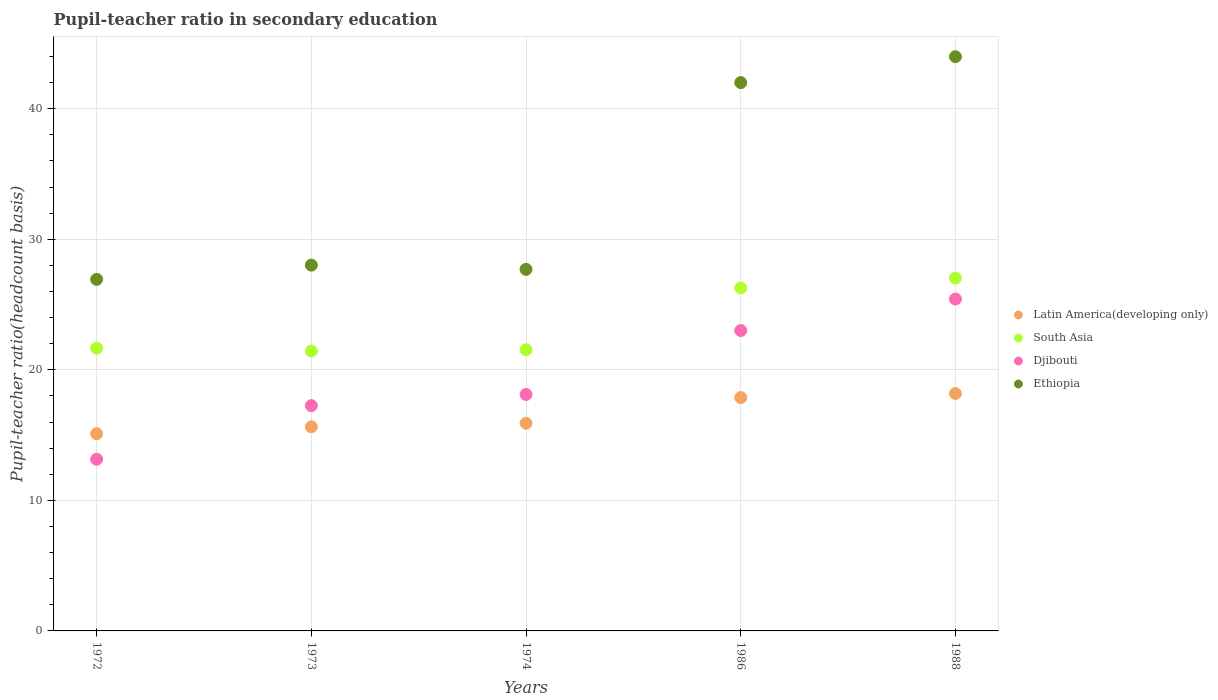How many different coloured dotlines are there?
Give a very brief answer. 4. Is the number of dotlines equal to the number of legend labels?
Your answer should be very brief. Yes. What is the pupil-teacher ratio in secondary education in Latin America(developing only) in 1974?
Provide a short and direct response. 15.91. Across all years, what is the maximum pupil-teacher ratio in secondary education in Latin America(developing only)?
Provide a short and direct response. 18.19. Across all years, what is the minimum pupil-teacher ratio in secondary education in Latin America(developing only)?
Your answer should be very brief. 15.11. What is the total pupil-teacher ratio in secondary education in Latin America(developing only) in the graph?
Keep it short and to the point. 82.71. What is the difference between the pupil-teacher ratio in secondary education in Ethiopia in 1974 and that in 1988?
Your response must be concise. -16.29. What is the difference between the pupil-teacher ratio in secondary education in Ethiopia in 1988 and the pupil-teacher ratio in secondary education in Djibouti in 1974?
Your answer should be compact. 25.87. What is the average pupil-teacher ratio in secondary education in Djibouti per year?
Make the answer very short. 19.39. In the year 1986, what is the difference between the pupil-teacher ratio in secondary education in Djibouti and pupil-teacher ratio in secondary education in South Asia?
Your answer should be compact. -3.26. In how many years, is the pupil-teacher ratio in secondary education in Latin America(developing only) greater than 40?
Provide a succinct answer. 0. What is the ratio of the pupil-teacher ratio in secondary education in Latin America(developing only) in 1974 to that in 1988?
Give a very brief answer. 0.87. Is the difference between the pupil-teacher ratio in secondary education in Djibouti in 1972 and 1986 greater than the difference between the pupil-teacher ratio in secondary education in South Asia in 1972 and 1986?
Give a very brief answer. No. What is the difference between the highest and the second highest pupil-teacher ratio in secondary education in Latin America(developing only)?
Provide a short and direct response. 0.31. What is the difference between the highest and the lowest pupil-teacher ratio in secondary education in South Asia?
Provide a short and direct response. 5.59. Is it the case that in every year, the sum of the pupil-teacher ratio in secondary education in Ethiopia and pupil-teacher ratio in secondary education in Djibouti  is greater than the pupil-teacher ratio in secondary education in Latin America(developing only)?
Make the answer very short. Yes. Is the pupil-teacher ratio in secondary education in Ethiopia strictly less than the pupil-teacher ratio in secondary education in Latin America(developing only) over the years?
Keep it short and to the point. No. What is the difference between two consecutive major ticks on the Y-axis?
Give a very brief answer. 10. Does the graph contain any zero values?
Offer a terse response. No. Does the graph contain grids?
Ensure brevity in your answer.  Yes. Where does the legend appear in the graph?
Give a very brief answer. Center right. How many legend labels are there?
Offer a terse response. 4. What is the title of the graph?
Your response must be concise. Pupil-teacher ratio in secondary education. Does "East Asia (all income levels)" appear as one of the legend labels in the graph?
Provide a short and direct response. No. What is the label or title of the Y-axis?
Ensure brevity in your answer.  Pupil-teacher ratio(headcount basis). What is the Pupil-teacher ratio(headcount basis) in Latin America(developing only) in 1972?
Your answer should be very brief. 15.11. What is the Pupil-teacher ratio(headcount basis) in South Asia in 1972?
Give a very brief answer. 21.66. What is the Pupil-teacher ratio(headcount basis) of Djibouti in 1972?
Your answer should be very brief. 13.15. What is the Pupil-teacher ratio(headcount basis) in Ethiopia in 1972?
Your answer should be very brief. 26.93. What is the Pupil-teacher ratio(headcount basis) of Latin America(developing only) in 1973?
Give a very brief answer. 15.63. What is the Pupil-teacher ratio(headcount basis) in South Asia in 1973?
Provide a succinct answer. 21.44. What is the Pupil-teacher ratio(headcount basis) of Djibouti in 1973?
Offer a very short reply. 17.26. What is the Pupil-teacher ratio(headcount basis) in Ethiopia in 1973?
Make the answer very short. 28.02. What is the Pupil-teacher ratio(headcount basis) in Latin America(developing only) in 1974?
Ensure brevity in your answer.  15.91. What is the Pupil-teacher ratio(headcount basis) of South Asia in 1974?
Your answer should be very brief. 21.54. What is the Pupil-teacher ratio(headcount basis) in Djibouti in 1974?
Provide a succinct answer. 18.11. What is the Pupil-teacher ratio(headcount basis) in Ethiopia in 1974?
Your answer should be very brief. 27.69. What is the Pupil-teacher ratio(headcount basis) of Latin America(developing only) in 1986?
Ensure brevity in your answer.  17.88. What is the Pupil-teacher ratio(headcount basis) of South Asia in 1986?
Provide a short and direct response. 26.27. What is the Pupil-teacher ratio(headcount basis) in Djibouti in 1986?
Your answer should be compact. 23.01. What is the Pupil-teacher ratio(headcount basis) of Ethiopia in 1986?
Ensure brevity in your answer.  42. What is the Pupil-teacher ratio(headcount basis) of Latin America(developing only) in 1988?
Provide a succinct answer. 18.19. What is the Pupil-teacher ratio(headcount basis) of South Asia in 1988?
Provide a succinct answer. 27.03. What is the Pupil-teacher ratio(headcount basis) of Djibouti in 1988?
Offer a very short reply. 25.43. What is the Pupil-teacher ratio(headcount basis) of Ethiopia in 1988?
Provide a succinct answer. 43.98. Across all years, what is the maximum Pupil-teacher ratio(headcount basis) in Latin America(developing only)?
Your answer should be compact. 18.19. Across all years, what is the maximum Pupil-teacher ratio(headcount basis) of South Asia?
Offer a terse response. 27.03. Across all years, what is the maximum Pupil-teacher ratio(headcount basis) in Djibouti?
Your answer should be very brief. 25.43. Across all years, what is the maximum Pupil-teacher ratio(headcount basis) in Ethiopia?
Provide a succinct answer. 43.98. Across all years, what is the minimum Pupil-teacher ratio(headcount basis) of Latin America(developing only)?
Ensure brevity in your answer.  15.11. Across all years, what is the minimum Pupil-teacher ratio(headcount basis) of South Asia?
Offer a terse response. 21.44. Across all years, what is the minimum Pupil-teacher ratio(headcount basis) of Djibouti?
Provide a succinct answer. 13.15. Across all years, what is the minimum Pupil-teacher ratio(headcount basis) of Ethiopia?
Your response must be concise. 26.93. What is the total Pupil-teacher ratio(headcount basis) in Latin America(developing only) in the graph?
Provide a short and direct response. 82.71. What is the total Pupil-teacher ratio(headcount basis) in South Asia in the graph?
Keep it short and to the point. 117.93. What is the total Pupil-teacher ratio(headcount basis) in Djibouti in the graph?
Your answer should be compact. 96.96. What is the total Pupil-teacher ratio(headcount basis) in Ethiopia in the graph?
Make the answer very short. 168.63. What is the difference between the Pupil-teacher ratio(headcount basis) of Latin America(developing only) in 1972 and that in 1973?
Ensure brevity in your answer.  -0.53. What is the difference between the Pupil-teacher ratio(headcount basis) in South Asia in 1972 and that in 1973?
Provide a succinct answer. 0.22. What is the difference between the Pupil-teacher ratio(headcount basis) of Djibouti in 1972 and that in 1973?
Your answer should be very brief. -4.11. What is the difference between the Pupil-teacher ratio(headcount basis) of Ethiopia in 1972 and that in 1973?
Your response must be concise. -1.09. What is the difference between the Pupil-teacher ratio(headcount basis) of Latin America(developing only) in 1972 and that in 1974?
Your answer should be compact. -0.8. What is the difference between the Pupil-teacher ratio(headcount basis) of South Asia in 1972 and that in 1974?
Offer a very short reply. 0.12. What is the difference between the Pupil-teacher ratio(headcount basis) in Djibouti in 1972 and that in 1974?
Provide a succinct answer. -4.96. What is the difference between the Pupil-teacher ratio(headcount basis) of Ethiopia in 1972 and that in 1974?
Your response must be concise. -0.76. What is the difference between the Pupil-teacher ratio(headcount basis) in Latin America(developing only) in 1972 and that in 1986?
Your answer should be very brief. -2.77. What is the difference between the Pupil-teacher ratio(headcount basis) in South Asia in 1972 and that in 1986?
Make the answer very short. -4.61. What is the difference between the Pupil-teacher ratio(headcount basis) of Djibouti in 1972 and that in 1986?
Your response must be concise. -9.86. What is the difference between the Pupil-teacher ratio(headcount basis) in Ethiopia in 1972 and that in 1986?
Make the answer very short. -15.07. What is the difference between the Pupil-teacher ratio(headcount basis) of Latin America(developing only) in 1972 and that in 1988?
Provide a short and direct response. -3.08. What is the difference between the Pupil-teacher ratio(headcount basis) of South Asia in 1972 and that in 1988?
Your response must be concise. -5.37. What is the difference between the Pupil-teacher ratio(headcount basis) in Djibouti in 1972 and that in 1988?
Make the answer very short. -12.28. What is the difference between the Pupil-teacher ratio(headcount basis) of Ethiopia in 1972 and that in 1988?
Make the answer very short. -17.05. What is the difference between the Pupil-teacher ratio(headcount basis) in Latin America(developing only) in 1973 and that in 1974?
Keep it short and to the point. -0.27. What is the difference between the Pupil-teacher ratio(headcount basis) in South Asia in 1973 and that in 1974?
Keep it short and to the point. -0.1. What is the difference between the Pupil-teacher ratio(headcount basis) of Djibouti in 1973 and that in 1974?
Offer a very short reply. -0.86. What is the difference between the Pupil-teacher ratio(headcount basis) in Ethiopia in 1973 and that in 1974?
Make the answer very short. 0.33. What is the difference between the Pupil-teacher ratio(headcount basis) of Latin America(developing only) in 1973 and that in 1986?
Make the answer very short. -2.24. What is the difference between the Pupil-teacher ratio(headcount basis) in South Asia in 1973 and that in 1986?
Provide a short and direct response. -4.83. What is the difference between the Pupil-teacher ratio(headcount basis) of Djibouti in 1973 and that in 1986?
Give a very brief answer. -5.75. What is the difference between the Pupil-teacher ratio(headcount basis) in Ethiopia in 1973 and that in 1986?
Provide a short and direct response. -13.98. What is the difference between the Pupil-teacher ratio(headcount basis) of Latin America(developing only) in 1973 and that in 1988?
Give a very brief answer. -2.55. What is the difference between the Pupil-teacher ratio(headcount basis) of South Asia in 1973 and that in 1988?
Your answer should be very brief. -5.59. What is the difference between the Pupil-teacher ratio(headcount basis) in Djibouti in 1973 and that in 1988?
Make the answer very short. -8.17. What is the difference between the Pupil-teacher ratio(headcount basis) of Ethiopia in 1973 and that in 1988?
Your response must be concise. -15.96. What is the difference between the Pupil-teacher ratio(headcount basis) of Latin America(developing only) in 1974 and that in 1986?
Your answer should be compact. -1.97. What is the difference between the Pupil-teacher ratio(headcount basis) in South Asia in 1974 and that in 1986?
Ensure brevity in your answer.  -4.73. What is the difference between the Pupil-teacher ratio(headcount basis) in Djibouti in 1974 and that in 1986?
Keep it short and to the point. -4.9. What is the difference between the Pupil-teacher ratio(headcount basis) of Ethiopia in 1974 and that in 1986?
Your answer should be very brief. -14.31. What is the difference between the Pupil-teacher ratio(headcount basis) of Latin America(developing only) in 1974 and that in 1988?
Offer a very short reply. -2.28. What is the difference between the Pupil-teacher ratio(headcount basis) in South Asia in 1974 and that in 1988?
Your answer should be compact. -5.49. What is the difference between the Pupil-teacher ratio(headcount basis) in Djibouti in 1974 and that in 1988?
Offer a very short reply. -7.31. What is the difference between the Pupil-teacher ratio(headcount basis) in Ethiopia in 1974 and that in 1988?
Make the answer very short. -16.29. What is the difference between the Pupil-teacher ratio(headcount basis) in Latin America(developing only) in 1986 and that in 1988?
Your answer should be very brief. -0.31. What is the difference between the Pupil-teacher ratio(headcount basis) of South Asia in 1986 and that in 1988?
Offer a very short reply. -0.76. What is the difference between the Pupil-teacher ratio(headcount basis) in Djibouti in 1986 and that in 1988?
Your response must be concise. -2.42. What is the difference between the Pupil-teacher ratio(headcount basis) in Ethiopia in 1986 and that in 1988?
Give a very brief answer. -1.98. What is the difference between the Pupil-teacher ratio(headcount basis) in Latin America(developing only) in 1972 and the Pupil-teacher ratio(headcount basis) in South Asia in 1973?
Provide a short and direct response. -6.33. What is the difference between the Pupil-teacher ratio(headcount basis) in Latin America(developing only) in 1972 and the Pupil-teacher ratio(headcount basis) in Djibouti in 1973?
Your answer should be very brief. -2.15. What is the difference between the Pupil-teacher ratio(headcount basis) in Latin America(developing only) in 1972 and the Pupil-teacher ratio(headcount basis) in Ethiopia in 1973?
Provide a succinct answer. -12.91. What is the difference between the Pupil-teacher ratio(headcount basis) in South Asia in 1972 and the Pupil-teacher ratio(headcount basis) in Djibouti in 1973?
Ensure brevity in your answer.  4.4. What is the difference between the Pupil-teacher ratio(headcount basis) in South Asia in 1972 and the Pupil-teacher ratio(headcount basis) in Ethiopia in 1973?
Offer a terse response. -6.36. What is the difference between the Pupil-teacher ratio(headcount basis) of Djibouti in 1972 and the Pupil-teacher ratio(headcount basis) of Ethiopia in 1973?
Provide a succinct answer. -14.87. What is the difference between the Pupil-teacher ratio(headcount basis) in Latin America(developing only) in 1972 and the Pupil-teacher ratio(headcount basis) in South Asia in 1974?
Make the answer very short. -6.43. What is the difference between the Pupil-teacher ratio(headcount basis) in Latin America(developing only) in 1972 and the Pupil-teacher ratio(headcount basis) in Djibouti in 1974?
Provide a short and direct response. -3.01. What is the difference between the Pupil-teacher ratio(headcount basis) of Latin America(developing only) in 1972 and the Pupil-teacher ratio(headcount basis) of Ethiopia in 1974?
Make the answer very short. -12.59. What is the difference between the Pupil-teacher ratio(headcount basis) of South Asia in 1972 and the Pupil-teacher ratio(headcount basis) of Djibouti in 1974?
Make the answer very short. 3.54. What is the difference between the Pupil-teacher ratio(headcount basis) of South Asia in 1972 and the Pupil-teacher ratio(headcount basis) of Ethiopia in 1974?
Your answer should be very brief. -6.04. What is the difference between the Pupil-teacher ratio(headcount basis) of Djibouti in 1972 and the Pupil-teacher ratio(headcount basis) of Ethiopia in 1974?
Your answer should be compact. -14.54. What is the difference between the Pupil-teacher ratio(headcount basis) of Latin America(developing only) in 1972 and the Pupil-teacher ratio(headcount basis) of South Asia in 1986?
Keep it short and to the point. -11.16. What is the difference between the Pupil-teacher ratio(headcount basis) in Latin America(developing only) in 1972 and the Pupil-teacher ratio(headcount basis) in Djibouti in 1986?
Ensure brevity in your answer.  -7.9. What is the difference between the Pupil-teacher ratio(headcount basis) of Latin America(developing only) in 1972 and the Pupil-teacher ratio(headcount basis) of Ethiopia in 1986?
Your answer should be very brief. -26.89. What is the difference between the Pupil-teacher ratio(headcount basis) of South Asia in 1972 and the Pupil-teacher ratio(headcount basis) of Djibouti in 1986?
Ensure brevity in your answer.  -1.35. What is the difference between the Pupil-teacher ratio(headcount basis) of South Asia in 1972 and the Pupil-teacher ratio(headcount basis) of Ethiopia in 1986?
Ensure brevity in your answer.  -20.34. What is the difference between the Pupil-teacher ratio(headcount basis) of Djibouti in 1972 and the Pupil-teacher ratio(headcount basis) of Ethiopia in 1986?
Keep it short and to the point. -28.85. What is the difference between the Pupil-teacher ratio(headcount basis) of Latin America(developing only) in 1972 and the Pupil-teacher ratio(headcount basis) of South Asia in 1988?
Your response must be concise. -11.92. What is the difference between the Pupil-teacher ratio(headcount basis) in Latin America(developing only) in 1972 and the Pupil-teacher ratio(headcount basis) in Djibouti in 1988?
Your answer should be very brief. -10.32. What is the difference between the Pupil-teacher ratio(headcount basis) of Latin America(developing only) in 1972 and the Pupil-teacher ratio(headcount basis) of Ethiopia in 1988?
Ensure brevity in your answer.  -28.88. What is the difference between the Pupil-teacher ratio(headcount basis) in South Asia in 1972 and the Pupil-teacher ratio(headcount basis) in Djibouti in 1988?
Your answer should be very brief. -3.77. What is the difference between the Pupil-teacher ratio(headcount basis) of South Asia in 1972 and the Pupil-teacher ratio(headcount basis) of Ethiopia in 1988?
Ensure brevity in your answer.  -22.33. What is the difference between the Pupil-teacher ratio(headcount basis) in Djibouti in 1972 and the Pupil-teacher ratio(headcount basis) in Ethiopia in 1988?
Your answer should be compact. -30.83. What is the difference between the Pupil-teacher ratio(headcount basis) of Latin America(developing only) in 1973 and the Pupil-teacher ratio(headcount basis) of South Asia in 1974?
Ensure brevity in your answer.  -5.9. What is the difference between the Pupil-teacher ratio(headcount basis) of Latin America(developing only) in 1973 and the Pupil-teacher ratio(headcount basis) of Djibouti in 1974?
Your response must be concise. -2.48. What is the difference between the Pupil-teacher ratio(headcount basis) in Latin America(developing only) in 1973 and the Pupil-teacher ratio(headcount basis) in Ethiopia in 1974?
Your response must be concise. -12.06. What is the difference between the Pupil-teacher ratio(headcount basis) of South Asia in 1973 and the Pupil-teacher ratio(headcount basis) of Djibouti in 1974?
Make the answer very short. 3.33. What is the difference between the Pupil-teacher ratio(headcount basis) in South Asia in 1973 and the Pupil-teacher ratio(headcount basis) in Ethiopia in 1974?
Keep it short and to the point. -6.25. What is the difference between the Pupil-teacher ratio(headcount basis) in Djibouti in 1973 and the Pupil-teacher ratio(headcount basis) in Ethiopia in 1974?
Provide a succinct answer. -10.44. What is the difference between the Pupil-teacher ratio(headcount basis) in Latin America(developing only) in 1973 and the Pupil-teacher ratio(headcount basis) in South Asia in 1986?
Ensure brevity in your answer.  -10.63. What is the difference between the Pupil-teacher ratio(headcount basis) in Latin America(developing only) in 1973 and the Pupil-teacher ratio(headcount basis) in Djibouti in 1986?
Give a very brief answer. -7.38. What is the difference between the Pupil-teacher ratio(headcount basis) in Latin America(developing only) in 1973 and the Pupil-teacher ratio(headcount basis) in Ethiopia in 1986?
Ensure brevity in your answer.  -26.37. What is the difference between the Pupil-teacher ratio(headcount basis) of South Asia in 1973 and the Pupil-teacher ratio(headcount basis) of Djibouti in 1986?
Give a very brief answer. -1.57. What is the difference between the Pupil-teacher ratio(headcount basis) in South Asia in 1973 and the Pupil-teacher ratio(headcount basis) in Ethiopia in 1986?
Ensure brevity in your answer.  -20.56. What is the difference between the Pupil-teacher ratio(headcount basis) of Djibouti in 1973 and the Pupil-teacher ratio(headcount basis) of Ethiopia in 1986?
Offer a very short reply. -24.74. What is the difference between the Pupil-teacher ratio(headcount basis) in Latin America(developing only) in 1973 and the Pupil-teacher ratio(headcount basis) in South Asia in 1988?
Provide a succinct answer. -11.39. What is the difference between the Pupil-teacher ratio(headcount basis) in Latin America(developing only) in 1973 and the Pupil-teacher ratio(headcount basis) in Djibouti in 1988?
Your response must be concise. -9.79. What is the difference between the Pupil-teacher ratio(headcount basis) of Latin America(developing only) in 1973 and the Pupil-teacher ratio(headcount basis) of Ethiopia in 1988?
Provide a short and direct response. -28.35. What is the difference between the Pupil-teacher ratio(headcount basis) in South Asia in 1973 and the Pupil-teacher ratio(headcount basis) in Djibouti in 1988?
Keep it short and to the point. -3.98. What is the difference between the Pupil-teacher ratio(headcount basis) of South Asia in 1973 and the Pupil-teacher ratio(headcount basis) of Ethiopia in 1988?
Your response must be concise. -22.54. What is the difference between the Pupil-teacher ratio(headcount basis) in Djibouti in 1973 and the Pupil-teacher ratio(headcount basis) in Ethiopia in 1988?
Offer a very short reply. -26.73. What is the difference between the Pupil-teacher ratio(headcount basis) in Latin America(developing only) in 1974 and the Pupil-teacher ratio(headcount basis) in South Asia in 1986?
Make the answer very short. -10.36. What is the difference between the Pupil-teacher ratio(headcount basis) in Latin America(developing only) in 1974 and the Pupil-teacher ratio(headcount basis) in Djibouti in 1986?
Your response must be concise. -7.1. What is the difference between the Pupil-teacher ratio(headcount basis) of Latin America(developing only) in 1974 and the Pupil-teacher ratio(headcount basis) of Ethiopia in 1986?
Offer a terse response. -26.09. What is the difference between the Pupil-teacher ratio(headcount basis) in South Asia in 1974 and the Pupil-teacher ratio(headcount basis) in Djibouti in 1986?
Your answer should be compact. -1.47. What is the difference between the Pupil-teacher ratio(headcount basis) of South Asia in 1974 and the Pupil-teacher ratio(headcount basis) of Ethiopia in 1986?
Ensure brevity in your answer.  -20.46. What is the difference between the Pupil-teacher ratio(headcount basis) in Djibouti in 1974 and the Pupil-teacher ratio(headcount basis) in Ethiopia in 1986?
Make the answer very short. -23.89. What is the difference between the Pupil-teacher ratio(headcount basis) of Latin America(developing only) in 1974 and the Pupil-teacher ratio(headcount basis) of South Asia in 1988?
Ensure brevity in your answer.  -11.12. What is the difference between the Pupil-teacher ratio(headcount basis) in Latin America(developing only) in 1974 and the Pupil-teacher ratio(headcount basis) in Djibouti in 1988?
Provide a short and direct response. -9.52. What is the difference between the Pupil-teacher ratio(headcount basis) in Latin America(developing only) in 1974 and the Pupil-teacher ratio(headcount basis) in Ethiopia in 1988?
Give a very brief answer. -28.08. What is the difference between the Pupil-teacher ratio(headcount basis) in South Asia in 1974 and the Pupil-teacher ratio(headcount basis) in Djibouti in 1988?
Provide a short and direct response. -3.89. What is the difference between the Pupil-teacher ratio(headcount basis) of South Asia in 1974 and the Pupil-teacher ratio(headcount basis) of Ethiopia in 1988?
Offer a terse response. -22.45. What is the difference between the Pupil-teacher ratio(headcount basis) of Djibouti in 1974 and the Pupil-teacher ratio(headcount basis) of Ethiopia in 1988?
Keep it short and to the point. -25.87. What is the difference between the Pupil-teacher ratio(headcount basis) in Latin America(developing only) in 1986 and the Pupil-teacher ratio(headcount basis) in South Asia in 1988?
Make the answer very short. -9.15. What is the difference between the Pupil-teacher ratio(headcount basis) of Latin America(developing only) in 1986 and the Pupil-teacher ratio(headcount basis) of Djibouti in 1988?
Your answer should be very brief. -7.55. What is the difference between the Pupil-teacher ratio(headcount basis) in Latin America(developing only) in 1986 and the Pupil-teacher ratio(headcount basis) in Ethiopia in 1988?
Make the answer very short. -26.11. What is the difference between the Pupil-teacher ratio(headcount basis) of South Asia in 1986 and the Pupil-teacher ratio(headcount basis) of Djibouti in 1988?
Offer a very short reply. 0.84. What is the difference between the Pupil-teacher ratio(headcount basis) of South Asia in 1986 and the Pupil-teacher ratio(headcount basis) of Ethiopia in 1988?
Provide a succinct answer. -17.72. What is the difference between the Pupil-teacher ratio(headcount basis) of Djibouti in 1986 and the Pupil-teacher ratio(headcount basis) of Ethiopia in 1988?
Offer a terse response. -20.98. What is the average Pupil-teacher ratio(headcount basis) in Latin America(developing only) per year?
Offer a very short reply. 16.54. What is the average Pupil-teacher ratio(headcount basis) of South Asia per year?
Make the answer very short. 23.59. What is the average Pupil-teacher ratio(headcount basis) in Djibouti per year?
Your answer should be compact. 19.39. What is the average Pupil-teacher ratio(headcount basis) in Ethiopia per year?
Your answer should be very brief. 33.73. In the year 1972, what is the difference between the Pupil-teacher ratio(headcount basis) in Latin America(developing only) and Pupil-teacher ratio(headcount basis) in South Asia?
Give a very brief answer. -6.55. In the year 1972, what is the difference between the Pupil-teacher ratio(headcount basis) in Latin America(developing only) and Pupil-teacher ratio(headcount basis) in Djibouti?
Make the answer very short. 1.96. In the year 1972, what is the difference between the Pupil-teacher ratio(headcount basis) in Latin America(developing only) and Pupil-teacher ratio(headcount basis) in Ethiopia?
Your response must be concise. -11.82. In the year 1972, what is the difference between the Pupil-teacher ratio(headcount basis) in South Asia and Pupil-teacher ratio(headcount basis) in Djibouti?
Make the answer very short. 8.51. In the year 1972, what is the difference between the Pupil-teacher ratio(headcount basis) of South Asia and Pupil-teacher ratio(headcount basis) of Ethiopia?
Your response must be concise. -5.28. In the year 1972, what is the difference between the Pupil-teacher ratio(headcount basis) in Djibouti and Pupil-teacher ratio(headcount basis) in Ethiopia?
Your answer should be compact. -13.78. In the year 1973, what is the difference between the Pupil-teacher ratio(headcount basis) of Latin America(developing only) and Pupil-teacher ratio(headcount basis) of South Asia?
Give a very brief answer. -5.81. In the year 1973, what is the difference between the Pupil-teacher ratio(headcount basis) in Latin America(developing only) and Pupil-teacher ratio(headcount basis) in Djibouti?
Ensure brevity in your answer.  -1.62. In the year 1973, what is the difference between the Pupil-teacher ratio(headcount basis) of Latin America(developing only) and Pupil-teacher ratio(headcount basis) of Ethiopia?
Provide a succinct answer. -12.39. In the year 1973, what is the difference between the Pupil-teacher ratio(headcount basis) of South Asia and Pupil-teacher ratio(headcount basis) of Djibouti?
Your response must be concise. 4.18. In the year 1973, what is the difference between the Pupil-teacher ratio(headcount basis) in South Asia and Pupil-teacher ratio(headcount basis) in Ethiopia?
Your answer should be very brief. -6.58. In the year 1973, what is the difference between the Pupil-teacher ratio(headcount basis) in Djibouti and Pupil-teacher ratio(headcount basis) in Ethiopia?
Your response must be concise. -10.76. In the year 1974, what is the difference between the Pupil-teacher ratio(headcount basis) in Latin America(developing only) and Pupil-teacher ratio(headcount basis) in South Asia?
Give a very brief answer. -5.63. In the year 1974, what is the difference between the Pupil-teacher ratio(headcount basis) of Latin America(developing only) and Pupil-teacher ratio(headcount basis) of Djibouti?
Give a very brief answer. -2.21. In the year 1974, what is the difference between the Pupil-teacher ratio(headcount basis) of Latin America(developing only) and Pupil-teacher ratio(headcount basis) of Ethiopia?
Give a very brief answer. -11.79. In the year 1974, what is the difference between the Pupil-teacher ratio(headcount basis) in South Asia and Pupil-teacher ratio(headcount basis) in Djibouti?
Make the answer very short. 3.42. In the year 1974, what is the difference between the Pupil-teacher ratio(headcount basis) in South Asia and Pupil-teacher ratio(headcount basis) in Ethiopia?
Provide a short and direct response. -6.16. In the year 1974, what is the difference between the Pupil-teacher ratio(headcount basis) in Djibouti and Pupil-teacher ratio(headcount basis) in Ethiopia?
Your answer should be very brief. -9.58. In the year 1986, what is the difference between the Pupil-teacher ratio(headcount basis) in Latin America(developing only) and Pupil-teacher ratio(headcount basis) in South Asia?
Provide a short and direct response. -8.39. In the year 1986, what is the difference between the Pupil-teacher ratio(headcount basis) of Latin America(developing only) and Pupil-teacher ratio(headcount basis) of Djibouti?
Make the answer very short. -5.13. In the year 1986, what is the difference between the Pupil-teacher ratio(headcount basis) of Latin America(developing only) and Pupil-teacher ratio(headcount basis) of Ethiopia?
Make the answer very short. -24.13. In the year 1986, what is the difference between the Pupil-teacher ratio(headcount basis) of South Asia and Pupil-teacher ratio(headcount basis) of Djibouti?
Your answer should be compact. 3.26. In the year 1986, what is the difference between the Pupil-teacher ratio(headcount basis) in South Asia and Pupil-teacher ratio(headcount basis) in Ethiopia?
Ensure brevity in your answer.  -15.73. In the year 1986, what is the difference between the Pupil-teacher ratio(headcount basis) in Djibouti and Pupil-teacher ratio(headcount basis) in Ethiopia?
Provide a succinct answer. -18.99. In the year 1988, what is the difference between the Pupil-teacher ratio(headcount basis) in Latin America(developing only) and Pupil-teacher ratio(headcount basis) in South Asia?
Keep it short and to the point. -8.84. In the year 1988, what is the difference between the Pupil-teacher ratio(headcount basis) of Latin America(developing only) and Pupil-teacher ratio(headcount basis) of Djibouti?
Offer a terse response. -7.24. In the year 1988, what is the difference between the Pupil-teacher ratio(headcount basis) of Latin America(developing only) and Pupil-teacher ratio(headcount basis) of Ethiopia?
Your response must be concise. -25.8. In the year 1988, what is the difference between the Pupil-teacher ratio(headcount basis) in South Asia and Pupil-teacher ratio(headcount basis) in Djibouti?
Provide a succinct answer. 1.6. In the year 1988, what is the difference between the Pupil-teacher ratio(headcount basis) in South Asia and Pupil-teacher ratio(headcount basis) in Ethiopia?
Offer a very short reply. -16.96. In the year 1988, what is the difference between the Pupil-teacher ratio(headcount basis) of Djibouti and Pupil-teacher ratio(headcount basis) of Ethiopia?
Keep it short and to the point. -18.56. What is the ratio of the Pupil-teacher ratio(headcount basis) in Latin America(developing only) in 1972 to that in 1973?
Give a very brief answer. 0.97. What is the ratio of the Pupil-teacher ratio(headcount basis) of South Asia in 1972 to that in 1973?
Your answer should be compact. 1.01. What is the ratio of the Pupil-teacher ratio(headcount basis) of Djibouti in 1972 to that in 1973?
Offer a terse response. 0.76. What is the ratio of the Pupil-teacher ratio(headcount basis) of Ethiopia in 1972 to that in 1973?
Offer a very short reply. 0.96. What is the ratio of the Pupil-teacher ratio(headcount basis) of Latin America(developing only) in 1972 to that in 1974?
Offer a very short reply. 0.95. What is the ratio of the Pupil-teacher ratio(headcount basis) in Djibouti in 1972 to that in 1974?
Your answer should be compact. 0.73. What is the ratio of the Pupil-teacher ratio(headcount basis) in Ethiopia in 1972 to that in 1974?
Offer a very short reply. 0.97. What is the ratio of the Pupil-teacher ratio(headcount basis) in Latin America(developing only) in 1972 to that in 1986?
Your response must be concise. 0.85. What is the ratio of the Pupil-teacher ratio(headcount basis) in South Asia in 1972 to that in 1986?
Offer a very short reply. 0.82. What is the ratio of the Pupil-teacher ratio(headcount basis) in Djibouti in 1972 to that in 1986?
Offer a very short reply. 0.57. What is the ratio of the Pupil-teacher ratio(headcount basis) in Ethiopia in 1972 to that in 1986?
Ensure brevity in your answer.  0.64. What is the ratio of the Pupil-teacher ratio(headcount basis) in Latin America(developing only) in 1972 to that in 1988?
Your response must be concise. 0.83. What is the ratio of the Pupil-teacher ratio(headcount basis) of South Asia in 1972 to that in 1988?
Your answer should be very brief. 0.8. What is the ratio of the Pupil-teacher ratio(headcount basis) of Djibouti in 1972 to that in 1988?
Your answer should be compact. 0.52. What is the ratio of the Pupil-teacher ratio(headcount basis) in Ethiopia in 1972 to that in 1988?
Provide a short and direct response. 0.61. What is the ratio of the Pupil-teacher ratio(headcount basis) in Latin America(developing only) in 1973 to that in 1974?
Your answer should be very brief. 0.98. What is the ratio of the Pupil-teacher ratio(headcount basis) in South Asia in 1973 to that in 1974?
Keep it short and to the point. 1. What is the ratio of the Pupil-teacher ratio(headcount basis) in Djibouti in 1973 to that in 1974?
Your response must be concise. 0.95. What is the ratio of the Pupil-teacher ratio(headcount basis) of Ethiopia in 1973 to that in 1974?
Your answer should be compact. 1.01. What is the ratio of the Pupil-teacher ratio(headcount basis) in Latin America(developing only) in 1973 to that in 1986?
Your answer should be compact. 0.87. What is the ratio of the Pupil-teacher ratio(headcount basis) of South Asia in 1973 to that in 1986?
Provide a short and direct response. 0.82. What is the ratio of the Pupil-teacher ratio(headcount basis) of Ethiopia in 1973 to that in 1986?
Offer a very short reply. 0.67. What is the ratio of the Pupil-teacher ratio(headcount basis) in Latin America(developing only) in 1973 to that in 1988?
Your answer should be compact. 0.86. What is the ratio of the Pupil-teacher ratio(headcount basis) of South Asia in 1973 to that in 1988?
Make the answer very short. 0.79. What is the ratio of the Pupil-teacher ratio(headcount basis) in Djibouti in 1973 to that in 1988?
Offer a very short reply. 0.68. What is the ratio of the Pupil-teacher ratio(headcount basis) of Ethiopia in 1973 to that in 1988?
Offer a terse response. 0.64. What is the ratio of the Pupil-teacher ratio(headcount basis) in Latin America(developing only) in 1974 to that in 1986?
Your answer should be compact. 0.89. What is the ratio of the Pupil-teacher ratio(headcount basis) of South Asia in 1974 to that in 1986?
Ensure brevity in your answer.  0.82. What is the ratio of the Pupil-teacher ratio(headcount basis) in Djibouti in 1974 to that in 1986?
Ensure brevity in your answer.  0.79. What is the ratio of the Pupil-teacher ratio(headcount basis) of Ethiopia in 1974 to that in 1986?
Make the answer very short. 0.66. What is the ratio of the Pupil-teacher ratio(headcount basis) of Latin America(developing only) in 1974 to that in 1988?
Provide a short and direct response. 0.87. What is the ratio of the Pupil-teacher ratio(headcount basis) in South Asia in 1974 to that in 1988?
Give a very brief answer. 0.8. What is the ratio of the Pupil-teacher ratio(headcount basis) in Djibouti in 1974 to that in 1988?
Your response must be concise. 0.71. What is the ratio of the Pupil-teacher ratio(headcount basis) in Ethiopia in 1974 to that in 1988?
Your answer should be very brief. 0.63. What is the ratio of the Pupil-teacher ratio(headcount basis) of Latin America(developing only) in 1986 to that in 1988?
Provide a succinct answer. 0.98. What is the ratio of the Pupil-teacher ratio(headcount basis) in South Asia in 1986 to that in 1988?
Ensure brevity in your answer.  0.97. What is the ratio of the Pupil-teacher ratio(headcount basis) in Djibouti in 1986 to that in 1988?
Your answer should be compact. 0.91. What is the ratio of the Pupil-teacher ratio(headcount basis) of Ethiopia in 1986 to that in 1988?
Give a very brief answer. 0.95. What is the difference between the highest and the second highest Pupil-teacher ratio(headcount basis) in Latin America(developing only)?
Your answer should be compact. 0.31. What is the difference between the highest and the second highest Pupil-teacher ratio(headcount basis) in South Asia?
Your answer should be very brief. 0.76. What is the difference between the highest and the second highest Pupil-teacher ratio(headcount basis) in Djibouti?
Offer a very short reply. 2.42. What is the difference between the highest and the second highest Pupil-teacher ratio(headcount basis) in Ethiopia?
Your answer should be very brief. 1.98. What is the difference between the highest and the lowest Pupil-teacher ratio(headcount basis) in Latin America(developing only)?
Keep it short and to the point. 3.08. What is the difference between the highest and the lowest Pupil-teacher ratio(headcount basis) in South Asia?
Your answer should be compact. 5.59. What is the difference between the highest and the lowest Pupil-teacher ratio(headcount basis) of Djibouti?
Give a very brief answer. 12.28. What is the difference between the highest and the lowest Pupil-teacher ratio(headcount basis) of Ethiopia?
Provide a short and direct response. 17.05. 